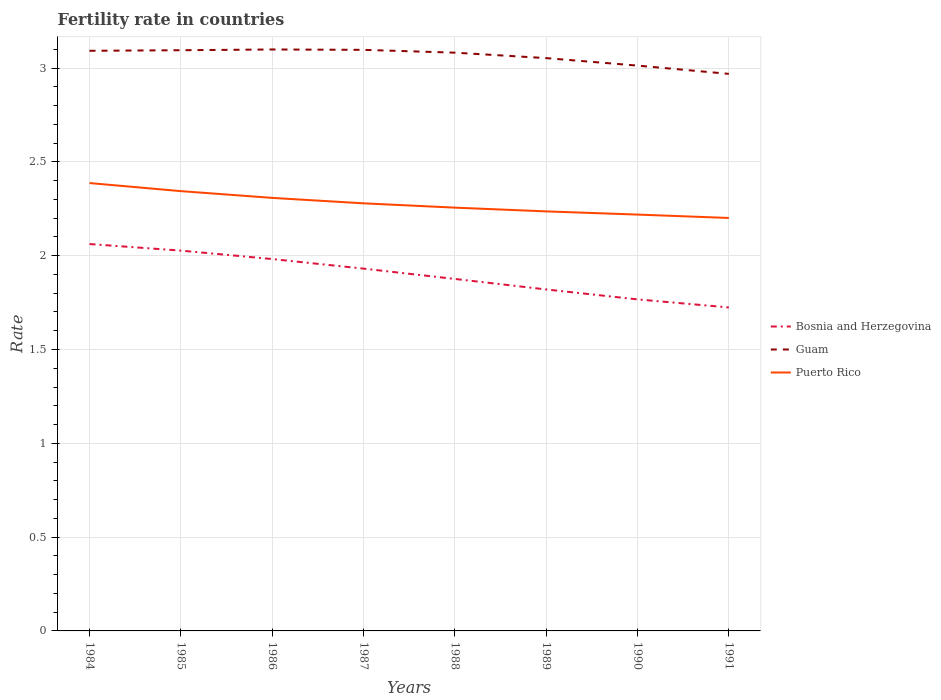Is the number of lines equal to the number of legend labels?
Ensure brevity in your answer.  Yes. Across all years, what is the maximum fertility rate in Bosnia and Herzegovina?
Keep it short and to the point. 1.72. In which year was the fertility rate in Bosnia and Herzegovina maximum?
Your answer should be very brief. 1991. What is the total fertility rate in Guam in the graph?
Your answer should be very brief. -0. What is the difference between the highest and the second highest fertility rate in Puerto Rico?
Your answer should be very brief. 0.19. Is the fertility rate in Puerto Rico strictly greater than the fertility rate in Bosnia and Herzegovina over the years?
Your answer should be very brief. No. How many lines are there?
Your answer should be compact. 3. How many years are there in the graph?
Your response must be concise. 8. How are the legend labels stacked?
Your response must be concise. Vertical. What is the title of the graph?
Provide a succinct answer. Fertility rate in countries. What is the label or title of the X-axis?
Offer a terse response. Years. What is the label or title of the Y-axis?
Your response must be concise. Rate. What is the Rate of Bosnia and Herzegovina in 1984?
Provide a succinct answer. 2.06. What is the Rate in Guam in 1984?
Ensure brevity in your answer.  3.09. What is the Rate in Puerto Rico in 1984?
Keep it short and to the point. 2.39. What is the Rate of Bosnia and Herzegovina in 1985?
Your answer should be very brief. 2.03. What is the Rate in Guam in 1985?
Your answer should be very brief. 3.1. What is the Rate of Puerto Rico in 1985?
Provide a succinct answer. 2.34. What is the Rate in Bosnia and Herzegovina in 1986?
Your response must be concise. 1.98. What is the Rate in Guam in 1986?
Your response must be concise. 3.1. What is the Rate in Puerto Rico in 1986?
Make the answer very short. 2.31. What is the Rate of Bosnia and Herzegovina in 1987?
Your answer should be compact. 1.93. What is the Rate of Guam in 1987?
Provide a succinct answer. 3.1. What is the Rate in Puerto Rico in 1987?
Provide a short and direct response. 2.28. What is the Rate of Bosnia and Herzegovina in 1988?
Offer a very short reply. 1.88. What is the Rate of Guam in 1988?
Keep it short and to the point. 3.08. What is the Rate of Puerto Rico in 1988?
Make the answer very short. 2.26. What is the Rate of Bosnia and Herzegovina in 1989?
Provide a succinct answer. 1.82. What is the Rate of Guam in 1989?
Provide a succinct answer. 3.05. What is the Rate of Puerto Rico in 1989?
Offer a terse response. 2.24. What is the Rate in Bosnia and Herzegovina in 1990?
Ensure brevity in your answer.  1.77. What is the Rate of Guam in 1990?
Offer a very short reply. 3.01. What is the Rate of Puerto Rico in 1990?
Provide a short and direct response. 2.22. What is the Rate in Bosnia and Herzegovina in 1991?
Your answer should be compact. 1.72. What is the Rate of Guam in 1991?
Keep it short and to the point. 2.97. What is the Rate in Puerto Rico in 1991?
Provide a short and direct response. 2.2. Across all years, what is the maximum Rate of Bosnia and Herzegovina?
Keep it short and to the point. 2.06. Across all years, what is the maximum Rate of Guam?
Provide a short and direct response. 3.1. Across all years, what is the maximum Rate of Puerto Rico?
Make the answer very short. 2.39. Across all years, what is the minimum Rate in Bosnia and Herzegovina?
Make the answer very short. 1.72. Across all years, what is the minimum Rate in Guam?
Give a very brief answer. 2.97. Across all years, what is the minimum Rate in Puerto Rico?
Ensure brevity in your answer.  2.2. What is the total Rate of Bosnia and Herzegovina in the graph?
Your answer should be very brief. 15.19. What is the total Rate in Guam in the graph?
Offer a terse response. 24.5. What is the total Rate in Puerto Rico in the graph?
Your answer should be compact. 18.23. What is the difference between the Rate of Bosnia and Herzegovina in 1984 and that in 1985?
Your answer should be very brief. 0.04. What is the difference between the Rate of Guam in 1984 and that in 1985?
Provide a short and direct response. -0. What is the difference between the Rate in Puerto Rico in 1984 and that in 1985?
Your answer should be very brief. 0.04. What is the difference between the Rate of Bosnia and Herzegovina in 1984 and that in 1986?
Give a very brief answer. 0.08. What is the difference between the Rate in Guam in 1984 and that in 1986?
Give a very brief answer. -0.01. What is the difference between the Rate of Puerto Rico in 1984 and that in 1986?
Provide a short and direct response. 0.08. What is the difference between the Rate in Bosnia and Herzegovina in 1984 and that in 1987?
Give a very brief answer. 0.13. What is the difference between the Rate in Guam in 1984 and that in 1987?
Make the answer very short. -0.01. What is the difference between the Rate in Puerto Rico in 1984 and that in 1987?
Provide a short and direct response. 0.11. What is the difference between the Rate in Bosnia and Herzegovina in 1984 and that in 1988?
Ensure brevity in your answer.  0.19. What is the difference between the Rate of Puerto Rico in 1984 and that in 1988?
Provide a succinct answer. 0.13. What is the difference between the Rate in Bosnia and Herzegovina in 1984 and that in 1989?
Keep it short and to the point. 0.24. What is the difference between the Rate of Guam in 1984 and that in 1989?
Your answer should be compact. 0.04. What is the difference between the Rate in Puerto Rico in 1984 and that in 1989?
Your answer should be very brief. 0.15. What is the difference between the Rate in Bosnia and Herzegovina in 1984 and that in 1990?
Your answer should be very brief. 0.29. What is the difference between the Rate of Guam in 1984 and that in 1990?
Keep it short and to the point. 0.08. What is the difference between the Rate of Puerto Rico in 1984 and that in 1990?
Make the answer very short. 0.17. What is the difference between the Rate of Bosnia and Herzegovina in 1984 and that in 1991?
Offer a terse response. 0.34. What is the difference between the Rate in Guam in 1984 and that in 1991?
Offer a very short reply. 0.12. What is the difference between the Rate in Puerto Rico in 1984 and that in 1991?
Your response must be concise. 0.19. What is the difference between the Rate of Bosnia and Herzegovina in 1985 and that in 1986?
Your answer should be compact. 0.04. What is the difference between the Rate of Guam in 1985 and that in 1986?
Your answer should be compact. -0. What is the difference between the Rate in Puerto Rico in 1985 and that in 1986?
Your answer should be very brief. 0.04. What is the difference between the Rate of Bosnia and Herzegovina in 1985 and that in 1987?
Offer a terse response. 0.1. What is the difference between the Rate of Guam in 1985 and that in 1987?
Give a very brief answer. -0. What is the difference between the Rate in Puerto Rico in 1985 and that in 1987?
Ensure brevity in your answer.  0.07. What is the difference between the Rate in Bosnia and Herzegovina in 1985 and that in 1988?
Offer a terse response. 0.15. What is the difference between the Rate in Guam in 1985 and that in 1988?
Give a very brief answer. 0.01. What is the difference between the Rate of Puerto Rico in 1985 and that in 1988?
Provide a short and direct response. 0.09. What is the difference between the Rate in Bosnia and Herzegovina in 1985 and that in 1989?
Keep it short and to the point. 0.21. What is the difference between the Rate in Guam in 1985 and that in 1989?
Your response must be concise. 0.04. What is the difference between the Rate of Puerto Rico in 1985 and that in 1989?
Your answer should be compact. 0.11. What is the difference between the Rate in Bosnia and Herzegovina in 1985 and that in 1990?
Offer a terse response. 0.26. What is the difference between the Rate of Guam in 1985 and that in 1990?
Provide a succinct answer. 0.08. What is the difference between the Rate in Bosnia and Herzegovina in 1985 and that in 1991?
Offer a very short reply. 0.3. What is the difference between the Rate of Guam in 1985 and that in 1991?
Provide a short and direct response. 0.13. What is the difference between the Rate of Puerto Rico in 1985 and that in 1991?
Keep it short and to the point. 0.14. What is the difference between the Rate in Bosnia and Herzegovina in 1986 and that in 1987?
Your response must be concise. 0.05. What is the difference between the Rate in Guam in 1986 and that in 1987?
Ensure brevity in your answer.  0. What is the difference between the Rate of Puerto Rico in 1986 and that in 1987?
Ensure brevity in your answer.  0.03. What is the difference between the Rate of Bosnia and Herzegovina in 1986 and that in 1988?
Give a very brief answer. 0.11. What is the difference between the Rate of Guam in 1986 and that in 1988?
Offer a very short reply. 0.02. What is the difference between the Rate of Puerto Rico in 1986 and that in 1988?
Ensure brevity in your answer.  0.05. What is the difference between the Rate of Bosnia and Herzegovina in 1986 and that in 1989?
Ensure brevity in your answer.  0.16. What is the difference between the Rate in Guam in 1986 and that in 1989?
Your answer should be very brief. 0.05. What is the difference between the Rate in Puerto Rico in 1986 and that in 1989?
Your response must be concise. 0.07. What is the difference between the Rate in Bosnia and Herzegovina in 1986 and that in 1990?
Give a very brief answer. 0.21. What is the difference between the Rate in Guam in 1986 and that in 1990?
Make the answer very short. 0.09. What is the difference between the Rate of Puerto Rico in 1986 and that in 1990?
Provide a succinct answer. 0.09. What is the difference between the Rate in Bosnia and Herzegovina in 1986 and that in 1991?
Offer a terse response. 0.26. What is the difference between the Rate of Guam in 1986 and that in 1991?
Make the answer very short. 0.13. What is the difference between the Rate of Puerto Rico in 1986 and that in 1991?
Keep it short and to the point. 0.11. What is the difference between the Rate in Bosnia and Herzegovina in 1987 and that in 1988?
Your answer should be compact. 0.06. What is the difference between the Rate in Guam in 1987 and that in 1988?
Offer a terse response. 0.01. What is the difference between the Rate of Puerto Rico in 1987 and that in 1988?
Your answer should be very brief. 0.02. What is the difference between the Rate in Bosnia and Herzegovina in 1987 and that in 1989?
Offer a terse response. 0.11. What is the difference between the Rate of Guam in 1987 and that in 1989?
Offer a terse response. 0.04. What is the difference between the Rate in Puerto Rico in 1987 and that in 1989?
Provide a short and direct response. 0.04. What is the difference between the Rate in Bosnia and Herzegovina in 1987 and that in 1990?
Provide a short and direct response. 0.16. What is the difference between the Rate in Guam in 1987 and that in 1990?
Make the answer very short. 0.08. What is the difference between the Rate of Puerto Rico in 1987 and that in 1990?
Your response must be concise. 0.06. What is the difference between the Rate in Bosnia and Herzegovina in 1987 and that in 1991?
Provide a succinct answer. 0.21. What is the difference between the Rate in Guam in 1987 and that in 1991?
Make the answer very short. 0.13. What is the difference between the Rate of Puerto Rico in 1987 and that in 1991?
Your answer should be compact. 0.08. What is the difference between the Rate in Bosnia and Herzegovina in 1988 and that in 1989?
Provide a succinct answer. 0.06. What is the difference between the Rate of Guam in 1988 and that in 1989?
Your response must be concise. 0.03. What is the difference between the Rate in Bosnia and Herzegovina in 1988 and that in 1990?
Make the answer very short. 0.11. What is the difference between the Rate of Guam in 1988 and that in 1990?
Ensure brevity in your answer.  0.07. What is the difference between the Rate in Puerto Rico in 1988 and that in 1990?
Make the answer very short. 0.04. What is the difference between the Rate in Bosnia and Herzegovina in 1988 and that in 1991?
Offer a terse response. 0.15. What is the difference between the Rate in Guam in 1988 and that in 1991?
Offer a very short reply. 0.11. What is the difference between the Rate in Puerto Rico in 1988 and that in 1991?
Provide a succinct answer. 0.06. What is the difference between the Rate in Bosnia and Herzegovina in 1989 and that in 1990?
Provide a succinct answer. 0.05. What is the difference between the Rate of Puerto Rico in 1989 and that in 1990?
Your response must be concise. 0.02. What is the difference between the Rate in Bosnia and Herzegovina in 1989 and that in 1991?
Your response must be concise. 0.1. What is the difference between the Rate of Guam in 1989 and that in 1991?
Your answer should be very brief. 0.08. What is the difference between the Rate in Puerto Rico in 1989 and that in 1991?
Offer a terse response. 0.04. What is the difference between the Rate of Bosnia and Herzegovina in 1990 and that in 1991?
Make the answer very short. 0.04. What is the difference between the Rate in Guam in 1990 and that in 1991?
Provide a short and direct response. 0.04. What is the difference between the Rate of Puerto Rico in 1990 and that in 1991?
Make the answer very short. 0.02. What is the difference between the Rate of Bosnia and Herzegovina in 1984 and the Rate of Guam in 1985?
Make the answer very short. -1.03. What is the difference between the Rate in Bosnia and Herzegovina in 1984 and the Rate in Puerto Rico in 1985?
Keep it short and to the point. -0.28. What is the difference between the Rate in Guam in 1984 and the Rate in Puerto Rico in 1985?
Ensure brevity in your answer.  0.75. What is the difference between the Rate of Bosnia and Herzegovina in 1984 and the Rate of Guam in 1986?
Your response must be concise. -1.04. What is the difference between the Rate of Bosnia and Herzegovina in 1984 and the Rate of Puerto Rico in 1986?
Provide a short and direct response. -0.25. What is the difference between the Rate of Guam in 1984 and the Rate of Puerto Rico in 1986?
Your response must be concise. 0.78. What is the difference between the Rate in Bosnia and Herzegovina in 1984 and the Rate in Guam in 1987?
Offer a terse response. -1.03. What is the difference between the Rate in Bosnia and Herzegovina in 1984 and the Rate in Puerto Rico in 1987?
Your response must be concise. -0.22. What is the difference between the Rate of Guam in 1984 and the Rate of Puerto Rico in 1987?
Keep it short and to the point. 0.81. What is the difference between the Rate in Bosnia and Herzegovina in 1984 and the Rate in Guam in 1988?
Give a very brief answer. -1.02. What is the difference between the Rate in Bosnia and Herzegovina in 1984 and the Rate in Puerto Rico in 1988?
Your response must be concise. -0.19. What is the difference between the Rate of Guam in 1984 and the Rate of Puerto Rico in 1988?
Your answer should be compact. 0.84. What is the difference between the Rate in Bosnia and Herzegovina in 1984 and the Rate in Guam in 1989?
Ensure brevity in your answer.  -0.99. What is the difference between the Rate in Bosnia and Herzegovina in 1984 and the Rate in Puerto Rico in 1989?
Offer a terse response. -0.17. What is the difference between the Rate of Guam in 1984 and the Rate of Puerto Rico in 1989?
Keep it short and to the point. 0.86. What is the difference between the Rate in Bosnia and Herzegovina in 1984 and the Rate in Guam in 1990?
Provide a succinct answer. -0.95. What is the difference between the Rate in Bosnia and Herzegovina in 1984 and the Rate in Puerto Rico in 1990?
Offer a very short reply. -0.16. What is the difference between the Rate of Guam in 1984 and the Rate of Puerto Rico in 1990?
Keep it short and to the point. 0.87. What is the difference between the Rate of Bosnia and Herzegovina in 1984 and the Rate of Guam in 1991?
Your response must be concise. -0.91. What is the difference between the Rate of Bosnia and Herzegovina in 1984 and the Rate of Puerto Rico in 1991?
Give a very brief answer. -0.14. What is the difference between the Rate of Guam in 1984 and the Rate of Puerto Rico in 1991?
Your answer should be very brief. 0.89. What is the difference between the Rate of Bosnia and Herzegovina in 1985 and the Rate of Guam in 1986?
Give a very brief answer. -1.07. What is the difference between the Rate in Bosnia and Herzegovina in 1985 and the Rate in Puerto Rico in 1986?
Make the answer very short. -0.28. What is the difference between the Rate in Guam in 1985 and the Rate in Puerto Rico in 1986?
Your response must be concise. 0.79. What is the difference between the Rate of Bosnia and Herzegovina in 1985 and the Rate of Guam in 1987?
Provide a succinct answer. -1.07. What is the difference between the Rate in Bosnia and Herzegovina in 1985 and the Rate in Puerto Rico in 1987?
Provide a short and direct response. -0.25. What is the difference between the Rate of Guam in 1985 and the Rate of Puerto Rico in 1987?
Your answer should be very brief. 0.82. What is the difference between the Rate in Bosnia and Herzegovina in 1985 and the Rate in Guam in 1988?
Provide a succinct answer. -1.05. What is the difference between the Rate of Bosnia and Herzegovina in 1985 and the Rate of Puerto Rico in 1988?
Make the answer very short. -0.23. What is the difference between the Rate of Guam in 1985 and the Rate of Puerto Rico in 1988?
Your answer should be compact. 0.84. What is the difference between the Rate of Bosnia and Herzegovina in 1985 and the Rate of Guam in 1989?
Give a very brief answer. -1.03. What is the difference between the Rate in Bosnia and Herzegovina in 1985 and the Rate in Puerto Rico in 1989?
Offer a terse response. -0.21. What is the difference between the Rate in Guam in 1985 and the Rate in Puerto Rico in 1989?
Provide a short and direct response. 0.86. What is the difference between the Rate in Bosnia and Herzegovina in 1985 and the Rate in Guam in 1990?
Your response must be concise. -0.99. What is the difference between the Rate of Bosnia and Herzegovina in 1985 and the Rate of Puerto Rico in 1990?
Keep it short and to the point. -0.19. What is the difference between the Rate of Guam in 1985 and the Rate of Puerto Rico in 1990?
Your answer should be very brief. 0.88. What is the difference between the Rate of Bosnia and Herzegovina in 1985 and the Rate of Guam in 1991?
Make the answer very short. -0.94. What is the difference between the Rate in Bosnia and Herzegovina in 1985 and the Rate in Puerto Rico in 1991?
Your answer should be very brief. -0.17. What is the difference between the Rate in Guam in 1985 and the Rate in Puerto Rico in 1991?
Your response must be concise. 0.89. What is the difference between the Rate in Bosnia and Herzegovina in 1986 and the Rate in Guam in 1987?
Give a very brief answer. -1.11. What is the difference between the Rate in Bosnia and Herzegovina in 1986 and the Rate in Puerto Rico in 1987?
Offer a terse response. -0.3. What is the difference between the Rate in Guam in 1986 and the Rate in Puerto Rico in 1987?
Your response must be concise. 0.82. What is the difference between the Rate of Bosnia and Herzegovina in 1986 and the Rate of Puerto Rico in 1988?
Ensure brevity in your answer.  -0.27. What is the difference between the Rate in Guam in 1986 and the Rate in Puerto Rico in 1988?
Provide a succinct answer. 0.84. What is the difference between the Rate in Bosnia and Herzegovina in 1986 and the Rate in Guam in 1989?
Make the answer very short. -1.07. What is the difference between the Rate in Bosnia and Herzegovina in 1986 and the Rate in Puerto Rico in 1989?
Keep it short and to the point. -0.25. What is the difference between the Rate of Guam in 1986 and the Rate of Puerto Rico in 1989?
Provide a short and direct response. 0.86. What is the difference between the Rate in Bosnia and Herzegovina in 1986 and the Rate in Guam in 1990?
Give a very brief answer. -1.03. What is the difference between the Rate in Bosnia and Herzegovina in 1986 and the Rate in Puerto Rico in 1990?
Ensure brevity in your answer.  -0.24. What is the difference between the Rate in Bosnia and Herzegovina in 1986 and the Rate in Guam in 1991?
Provide a succinct answer. -0.99. What is the difference between the Rate of Bosnia and Herzegovina in 1986 and the Rate of Puerto Rico in 1991?
Offer a very short reply. -0.22. What is the difference between the Rate in Guam in 1986 and the Rate in Puerto Rico in 1991?
Provide a succinct answer. 0.9. What is the difference between the Rate of Bosnia and Herzegovina in 1987 and the Rate of Guam in 1988?
Provide a succinct answer. -1.15. What is the difference between the Rate of Bosnia and Herzegovina in 1987 and the Rate of Puerto Rico in 1988?
Give a very brief answer. -0.33. What is the difference between the Rate of Guam in 1987 and the Rate of Puerto Rico in 1988?
Ensure brevity in your answer.  0.84. What is the difference between the Rate in Bosnia and Herzegovina in 1987 and the Rate in Guam in 1989?
Provide a succinct answer. -1.12. What is the difference between the Rate of Bosnia and Herzegovina in 1987 and the Rate of Puerto Rico in 1989?
Give a very brief answer. -0.3. What is the difference between the Rate of Guam in 1987 and the Rate of Puerto Rico in 1989?
Give a very brief answer. 0.86. What is the difference between the Rate in Bosnia and Herzegovina in 1987 and the Rate in Guam in 1990?
Your answer should be compact. -1.08. What is the difference between the Rate of Bosnia and Herzegovina in 1987 and the Rate of Puerto Rico in 1990?
Provide a short and direct response. -0.29. What is the difference between the Rate in Guam in 1987 and the Rate in Puerto Rico in 1990?
Offer a terse response. 0.88. What is the difference between the Rate in Bosnia and Herzegovina in 1987 and the Rate in Guam in 1991?
Provide a succinct answer. -1.04. What is the difference between the Rate in Bosnia and Herzegovina in 1987 and the Rate in Puerto Rico in 1991?
Ensure brevity in your answer.  -0.27. What is the difference between the Rate of Guam in 1987 and the Rate of Puerto Rico in 1991?
Provide a succinct answer. 0.9. What is the difference between the Rate of Bosnia and Herzegovina in 1988 and the Rate of Guam in 1989?
Give a very brief answer. -1.18. What is the difference between the Rate of Bosnia and Herzegovina in 1988 and the Rate of Puerto Rico in 1989?
Ensure brevity in your answer.  -0.36. What is the difference between the Rate in Guam in 1988 and the Rate in Puerto Rico in 1989?
Provide a short and direct response. 0.85. What is the difference between the Rate of Bosnia and Herzegovina in 1988 and the Rate of Guam in 1990?
Ensure brevity in your answer.  -1.14. What is the difference between the Rate of Bosnia and Herzegovina in 1988 and the Rate of Puerto Rico in 1990?
Provide a succinct answer. -0.34. What is the difference between the Rate in Guam in 1988 and the Rate in Puerto Rico in 1990?
Make the answer very short. 0.86. What is the difference between the Rate of Bosnia and Herzegovina in 1988 and the Rate of Guam in 1991?
Keep it short and to the point. -1.09. What is the difference between the Rate of Bosnia and Herzegovina in 1988 and the Rate of Puerto Rico in 1991?
Your response must be concise. -0.33. What is the difference between the Rate of Guam in 1988 and the Rate of Puerto Rico in 1991?
Offer a very short reply. 0.88. What is the difference between the Rate in Bosnia and Herzegovina in 1989 and the Rate in Guam in 1990?
Offer a terse response. -1.19. What is the difference between the Rate in Bosnia and Herzegovina in 1989 and the Rate in Puerto Rico in 1990?
Offer a very short reply. -0.4. What is the difference between the Rate in Guam in 1989 and the Rate in Puerto Rico in 1990?
Your answer should be very brief. 0.83. What is the difference between the Rate in Bosnia and Herzegovina in 1989 and the Rate in Guam in 1991?
Your response must be concise. -1.15. What is the difference between the Rate of Bosnia and Herzegovina in 1989 and the Rate of Puerto Rico in 1991?
Offer a terse response. -0.38. What is the difference between the Rate of Guam in 1989 and the Rate of Puerto Rico in 1991?
Provide a short and direct response. 0.85. What is the difference between the Rate in Bosnia and Herzegovina in 1990 and the Rate in Guam in 1991?
Provide a succinct answer. -1.2. What is the difference between the Rate of Bosnia and Herzegovina in 1990 and the Rate of Puerto Rico in 1991?
Keep it short and to the point. -0.43. What is the difference between the Rate of Guam in 1990 and the Rate of Puerto Rico in 1991?
Keep it short and to the point. 0.81. What is the average Rate in Bosnia and Herzegovina per year?
Keep it short and to the point. 1.9. What is the average Rate in Guam per year?
Keep it short and to the point. 3.06. What is the average Rate in Puerto Rico per year?
Your answer should be very brief. 2.28. In the year 1984, what is the difference between the Rate of Bosnia and Herzegovina and Rate of Guam?
Make the answer very short. -1.03. In the year 1984, what is the difference between the Rate in Bosnia and Herzegovina and Rate in Puerto Rico?
Offer a terse response. -0.33. In the year 1984, what is the difference between the Rate of Guam and Rate of Puerto Rico?
Offer a very short reply. 0.7. In the year 1985, what is the difference between the Rate of Bosnia and Herzegovina and Rate of Guam?
Ensure brevity in your answer.  -1.07. In the year 1985, what is the difference between the Rate of Bosnia and Herzegovina and Rate of Puerto Rico?
Ensure brevity in your answer.  -0.32. In the year 1985, what is the difference between the Rate of Guam and Rate of Puerto Rico?
Offer a very short reply. 0.75. In the year 1986, what is the difference between the Rate of Bosnia and Herzegovina and Rate of Guam?
Make the answer very short. -1.12. In the year 1986, what is the difference between the Rate of Bosnia and Herzegovina and Rate of Puerto Rico?
Your answer should be compact. -0.33. In the year 1986, what is the difference between the Rate in Guam and Rate in Puerto Rico?
Make the answer very short. 0.79. In the year 1987, what is the difference between the Rate of Bosnia and Herzegovina and Rate of Guam?
Make the answer very short. -1.17. In the year 1987, what is the difference between the Rate in Bosnia and Herzegovina and Rate in Puerto Rico?
Provide a succinct answer. -0.35. In the year 1987, what is the difference between the Rate in Guam and Rate in Puerto Rico?
Your response must be concise. 0.82. In the year 1988, what is the difference between the Rate in Bosnia and Herzegovina and Rate in Guam?
Your answer should be compact. -1.21. In the year 1988, what is the difference between the Rate of Bosnia and Herzegovina and Rate of Puerto Rico?
Ensure brevity in your answer.  -0.38. In the year 1988, what is the difference between the Rate in Guam and Rate in Puerto Rico?
Offer a very short reply. 0.83. In the year 1989, what is the difference between the Rate in Bosnia and Herzegovina and Rate in Guam?
Ensure brevity in your answer.  -1.23. In the year 1989, what is the difference between the Rate of Bosnia and Herzegovina and Rate of Puerto Rico?
Provide a succinct answer. -0.42. In the year 1989, what is the difference between the Rate of Guam and Rate of Puerto Rico?
Offer a very short reply. 0.82. In the year 1990, what is the difference between the Rate in Bosnia and Herzegovina and Rate in Guam?
Your answer should be very brief. -1.25. In the year 1990, what is the difference between the Rate of Bosnia and Herzegovina and Rate of Puerto Rico?
Your answer should be very brief. -0.45. In the year 1990, what is the difference between the Rate of Guam and Rate of Puerto Rico?
Provide a succinct answer. 0.79. In the year 1991, what is the difference between the Rate in Bosnia and Herzegovina and Rate in Guam?
Keep it short and to the point. -1.25. In the year 1991, what is the difference between the Rate of Bosnia and Herzegovina and Rate of Puerto Rico?
Offer a terse response. -0.48. In the year 1991, what is the difference between the Rate in Guam and Rate in Puerto Rico?
Make the answer very short. 0.77. What is the ratio of the Rate of Bosnia and Herzegovina in 1984 to that in 1985?
Ensure brevity in your answer.  1.02. What is the ratio of the Rate of Puerto Rico in 1984 to that in 1985?
Offer a very short reply. 1.02. What is the ratio of the Rate of Bosnia and Herzegovina in 1984 to that in 1986?
Ensure brevity in your answer.  1.04. What is the ratio of the Rate of Guam in 1984 to that in 1986?
Keep it short and to the point. 1. What is the ratio of the Rate of Puerto Rico in 1984 to that in 1986?
Offer a terse response. 1.03. What is the ratio of the Rate of Bosnia and Herzegovina in 1984 to that in 1987?
Your response must be concise. 1.07. What is the ratio of the Rate of Guam in 1984 to that in 1987?
Your answer should be compact. 1. What is the ratio of the Rate of Puerto Rico in 1984 to that in 1987?
Provide a short and direct response. 1.05. What is the ratio of the Rate of Bosnia and Herzegovina in 1984 to that in 1988?
Offer a very short reply. 1.1. What is the ratio of the Rate of Puerto Rico in 1984 to that in 1988?
Make the answer very short. 1.06. What is the ratio of the Rate of Bosnia and Herzegovina in 1984 to that in 1989?
Your response must be concise. 1.13. What is the ratio of the Rate of Guam in 1984 to that in 1989?
Give a very brief answer. 1.01. What is the ratio of the Rate of Puerto Rico in 1984 to that in 1989?
Offer a terse response. 1.07. What is the ratio of the Rate of Bosnia and Herzegovina in 1984 to that in 1990?
Provide a short and direct response. 1.17. What is the ratio of the Rate of Guam in 1984 to that in 1990?
Make the answer very short. 1.03. What is the ratio of the Rate of Puerto Rico in 1984 to that in 1990?
Ensure brevity in your answer.  1.08. What is the ratio of the Rate in Bosnia and Herzegovina in 1984 to that in 1991?
Your answer should be compact. 1.2. What is the ratio of the Rate in Guam in 1984 to that in 1991?
Ensure brevity in your answer.  1.04. What is the ratio of the Rate in Puerto Rico in 1984 to that in 1991?
Your response must be concise. 1.08. What is the ratio of the Rate of Bosnia and Herzegovina in 1985 to that in 1986?
Your answer should be very brief. 1.02. What is the ratio of the Rate in Guam in 1985 to that in 1986?
Provide a succinct answer. 1. What is the ratio of the Rate of Puerto Rico in 1985 to that in 1986?
Provide a short and direct response. 1.02. What is the ratio of the Rate of Bosnia and Herzegovina in 1985 to that in 1987?
Make the answer very short. 1.05. What is the ratio of the Rate of Guam in 1985 to that in 1987?
Provide a succinct answer. 1. What is the ratio of the Rate of Puerto Rico in 1985 to that in 1987?
Your answer should be very brief. 1.03. What is the ratio of the Rate of Bosnia and Herzegovina in 1985 to that in 1988?
Give a very brief answer. 1.08. What is the ratio of the Rate in Puerto Rico in 1985 to that in 1988?
Your answer should be compact. 1.04. What is the ratio of the Rate of Bosnia and Herzegovina in 1985 to that in 1989?
Ensure brevity in your answer.  1.11. What is the ratio of the Rate in Guam in 1985 to that in 1989?
Keep it short and to the point. 1.01. What is the ratio of the Rate of Puerto Rico in 1985 to that in 1989?
Keep it short and to the point. 1.05. What is the ratio of the Rate of Bosnia and Herzegovina in 1985 to that in 1990?
Offer a very short reply. 1.15. What is the ratio of the Rate in Guam in 1985 to that in 1990?
Offer a very short reply. 1.03. What is the ratio of the Rate of Puerto Rico in 1985 to that in 1990?
Keep it short and to the point. 1.06. What is the ratio of the Rate of Bosnia and Herzegovina in 1985 to that in 1991?
Your answer should be compact. 1.18. What is the ratio of the Rate in Guam in 1985 to that in 1991?
Ensure brevity in your answer.  1.04. What is the ratio of the Rate in Puerto Rico in 1985 to that in 1991?
Make the answer very short. 1.06. What is the ratio of the Rate in Bosnia and Herzegovina in 1986 to that in 1987?
Provide a succinct answer. 1.03. What is the ratio of the Rate of Guam in 1986 to that in 1987?
Offer a very short reply. 1. What is the ratio of the Rate in Puerto Rico in 1986 to that in 1987?
Your response must be concise. 1.01. What is the ratio of the Rate in Bosnia and Herzegovina in 1986 to that in 1988?
Keep it short and to the point. 1.06. What is the ratio of the Rate in Guam in 1986 to that in 1988?
Offer a terse response. 1.01. What is the ratio of the Rate of Bosnia and Herzegovina in 1986 to that in 1989?
Make the answer very short. 1.09. What is the ratio of the Rate of Guam in 1986 to that in 1989?
Your response must be concise. 1.02. What is the ratio of the Rate of Puerto Rico in 1986 to that in 1989?
Keep it short and to the point. 1.03. What is the ratio of the Rate in Bosnia and Herzegovina in 1986 to that in 1990?
Your response must be concise. 1.12. What is the ratio of the Rate of Guam in 1986 to that in 1990?
Offer a very short reply. 1.03. What is the ratio of the Rate in Puerto Rico in 1986 to that in 1990?
Ensure brevity in your answer.  1.04. What is the ratio of the Rate of Bosnia and Herzegovina in 1986 to that in 1991?
Offer a very short reply. 1.15. What is the ratio of the Rate in Guam in 1986 to that in 1991?
Offer a terse response. 1.04. What is the ratio of the Rate in Puerto Rico in 1986 to that in 1991?
Offer a terse response. 1.05. What is the ratio of the Rate of Bosnia and Herzegovina in 1987 to that in 1988?
Ensure brevity in your answer.  1.03. What is the ratio of the Rate in Guam in 1987 to that in 1988?
Provide a succinct answer. 1. What is the ratio of the Rate in Puerto Rico in 1987 to that in 1988?
Your answer should be compact. 1.01. What is the ratio of the Rate in Bosnia and Herzegovina in 1987 to that in 1989?
Keep it short and to the point. 1.06. What is the ratio of the Rate in Guam in 1987 to that in 1989?
Offer a terse response. 1.01. What is the ratio of the Rate in Puerto Rico in 1987 to that in 1989?
Your answer should be compact. 1.02. What is the ratio of the Rate of Bosnia and Herzegovina in 1987 to that in 1990?
Offer a terse response. 1.09. What is the ratio of the Rate in Guam in 1987 to that in 1990?
Provide a succinct answer. 1.03. What is the ratio of the Rate in Bosnia and Herzegovina in 1987 to that in 1991?
Provide a short and direct response. 1.12. What is the ratio of the Rate of Guam in 1987 to that in 1991?
Give a very brief answer. 1.04. What is the ratio of the Rate of Puerto Rico in 1987 to that in 1991?
Offer a very short reply. 1.04. What is the ratio of the Rate in Bosnia and Herzegovina in 1988 to that in 1989?
Offer a terse response. 1.03. What is the ratio of the Rate in Guam in 1988 to that in 1989?
Offer a very short reply. 1.01. What is the ratio of the Rate in Puerto Rico in 1988 to that in 1989?
Provide a short and direct response. 1.01. What is the ratio of the Rate of Bosnia and Herzegovina in 1988 to that in 1990?
Your answer should be compact. 1.06. What is the ratio of the Rate of Guam in 1988 to that in 1990?
Keep it short and to the point. 1.02. What is the ratio of the Rate in Puerto Rico in 1988 to that in 1990?
Ensure brevity in your answer.  1.02. What is the ratio of the Rate of Bosnia and Herzegovina in 1988 to that in 1991?
Offer a very short reply. 1.09. What is the ratio of the Rate of Guam in 1988 to that in 1991?
Give a very brief answer. 1.04. What is the ratio of the Rate of Bosnia and Herzegovina in 1989 to that in 1990?
Provide a short and direct response. 1.03. What is the ratio of the Rate in Guam in 1989 to that in 1990?
Offer a terse response. 1.01. What is the ratio of the Rate of Puerto Rico in 1989 to that in 1990?
Provide a succinct answer. 1.01. What is the ratio of the Rate in Bosnia and Herzegovina in 1989 to that in 1991?
Offer a terse response. 1.06. What is the ratio of the Rate in Guam in 1989 to that in 1991?
Your answer should be very brief. 1.03. What is the ratio of the Rate in Puerto Rico in 1989 to that in 1991?
Your answer should be compact. 1.02. What is the ratio of the Rate in Bosnia and Herzegovina in 1990 to that in 1991?
Provide a succinct answer. 1.02. What is the ratio of the Rate of Guam in 1990 to that in 1991?
Provide a succinct answer. 1.01. What is the ratio of the Rate of Puerto Rico in 1990 to that in 1991?
Make the answer very short. 1.01. What is the difference between the highest and the second highest Rate in Bosnia and Herzegovina?
Your response must be concise. 0.04. What is the difference between the highest and the second highest Rate in Guam?
Offer a terse response. 0. What is the difference between the highest and the second highest Rate in Puerto Rico?
Offer a very short reply. 0.04. What is the difference between the highest and the lowest Rate in Bosnia and Herzegovina?
Keep it short and to the point. 0.34. What is the difference between the highest and the lowest Rate in Guam?
Offer a very short reply. 0.13. What is the difference between the highest and the lowest Rate of Puerto Rico?
Provide a succinct answer. 0.19. 